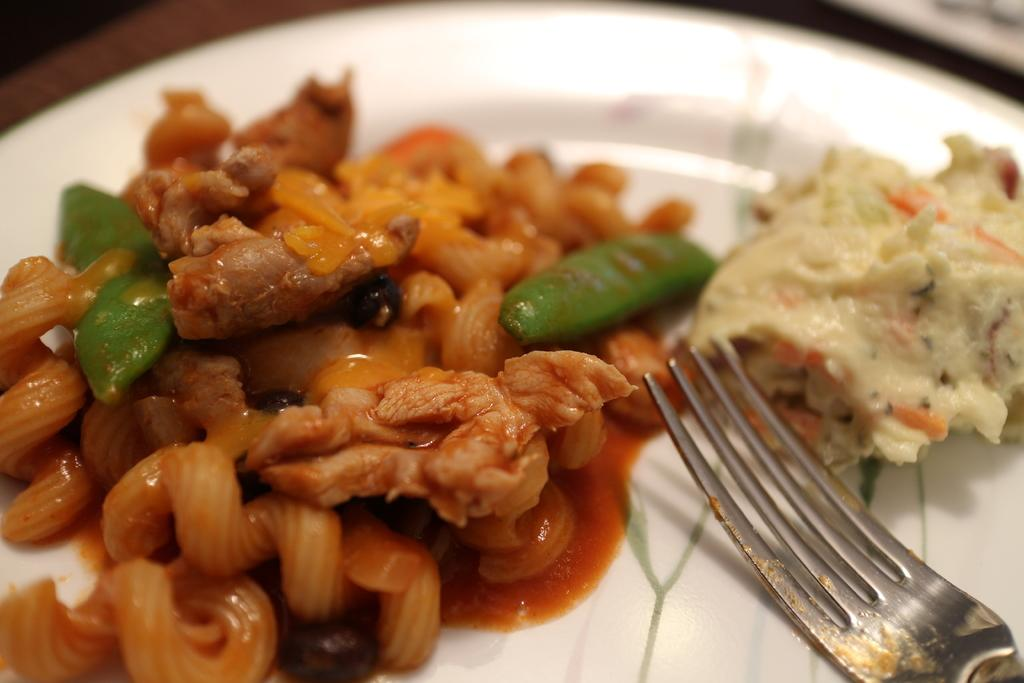What utensil is visible in the image? There is a fork in the image. What is on the plate in the image? There is a food item on a plate in the image. What color is the plate? The plate is white in color. Is there a bomb exploding in the image? No, there is no bomb or explosion present in the image. Can you see any smoke coming from the food item on the plate? No, there is no smoke visible in the image. 